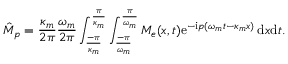Convert formula to latex. <formula><loc_0><loc_0><loc_500><loc_500>\hat { M } _ { p } = \frac { \kappa _ { m } } { 2 \pi } \frac { \omega _ { m } } { 2 \pi } \int _ { \frac { - \pi } { \kappa _ { m } } } ^ { \frac { \pi } { \kappa _ { m } } } \int _ { \frac { - \pi } { \omega _ { m } } } ^ { \frac { \pi } { \omega _ { m } } } M _ { e } ( x , t ) e ^ { - i p ( \omega _ { m } t - \kappa _ { m } x ) } \, d x d t .</formula> 